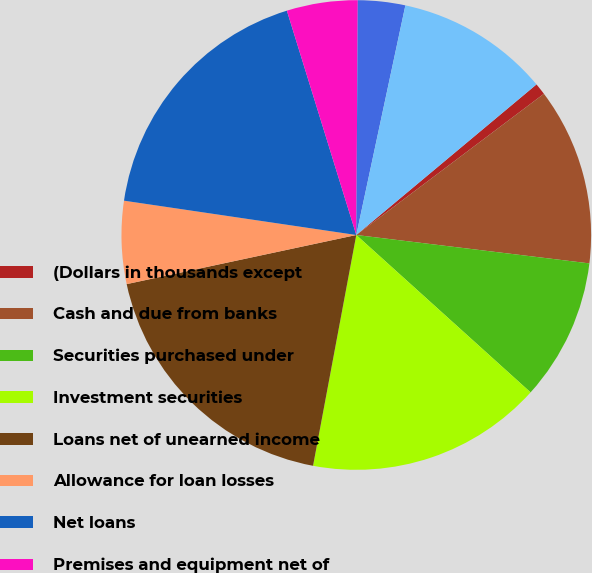Convert chart to OTSL. <chart><loc_0><loc_0><loc_500><loc_500><pie_chart><fcel>(Dollars in thousands except<fcel>Cash and due from banks<fcel>Securities purchased under<fcel>Investment securities<fcel>Loans net of unearned income<fcel>Allowance for loan losses<fcel>Net loans<fcel>Premises and equipment net of<fcel>Goodwill<fcel>Accrued interest receivable<nl><fcel>0.81%<fcel>12.2%<fcel>9.76%<fcel>16.26%<fcel>18.7%<fcel>5.69%<fcel>17.89%<fcel>4.88%<fcel>3.25%<fcel>10.57%<nl></chart> 